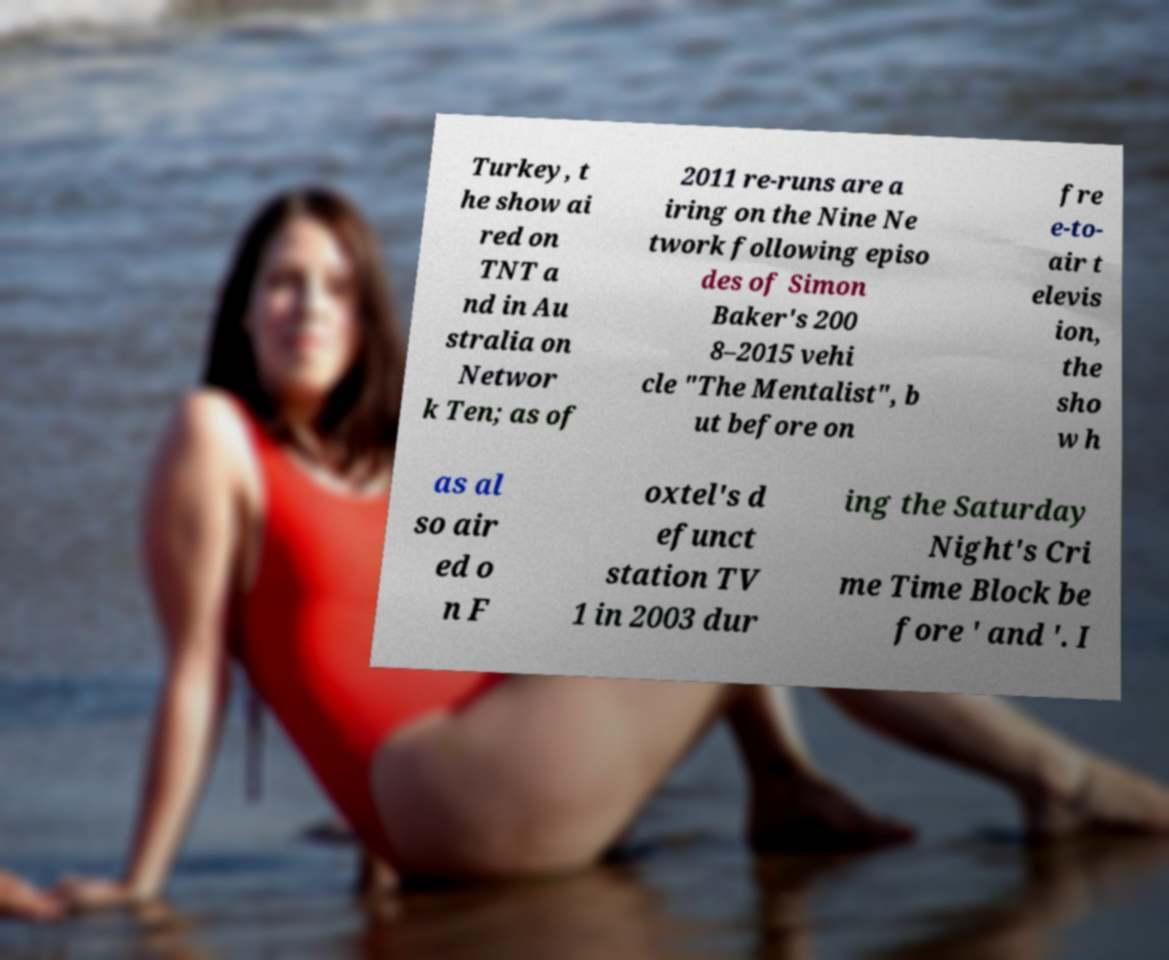Please read and relay the text visible in this image. What does it say? Turkey, t he show ai red on TNT a nd in Au stralia on Networ k Ten; as of 2011 re-runs are a iring on the Nine Ne twork following episo des of Simon Baker's 200 8–2015 vehi cle "The Mentalist", b ut before on fre e-to- air t elevis ion, the sho w h as al so air ed o n F oxtel's d efunct station TV 1 in 2003 dur ing the Saturday Night's Cri me Time Block be fore ' and '. I 